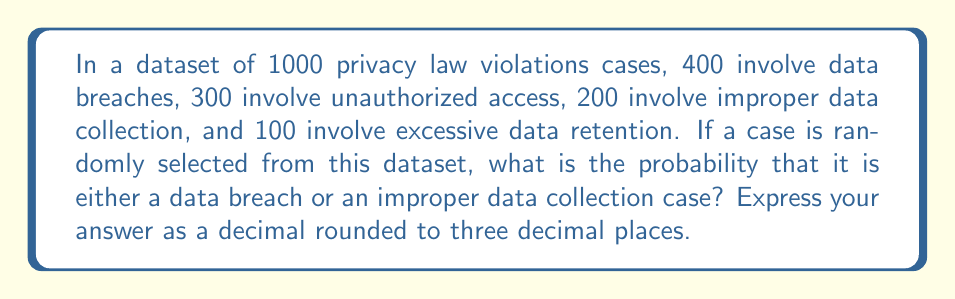Teach me how to tackle this problem. To solve this problem, we'll follow these steps:

1. Identify the total number of cases in the dataset:
   $N = 1000$

2. Identify the number of cases for each event:
   Data breaches: $A = 400$
   Improper data collection: $B = 200$

3. Calculate the probability of each event:
   $P(A) = \frac{A}{N} = \frac{400}{1000} = 0.4$
   $P(B) = \frac{B}{N} = \frac{200}{1000} = 0.2$

4. Since we want the probability of either a data breach or improper data collection case, we need to add these probabilities:
   $P(A \text{ or } B) = P(A) + P(B) = 0.4 + 0.2 = 0.6$

5. Round the result to three decimal places:
   $0.6 = 0.600$

Therefore, the probability of randomly selecting either a data breach or an improper data collection case is 0.600.
Answer: 0.600 